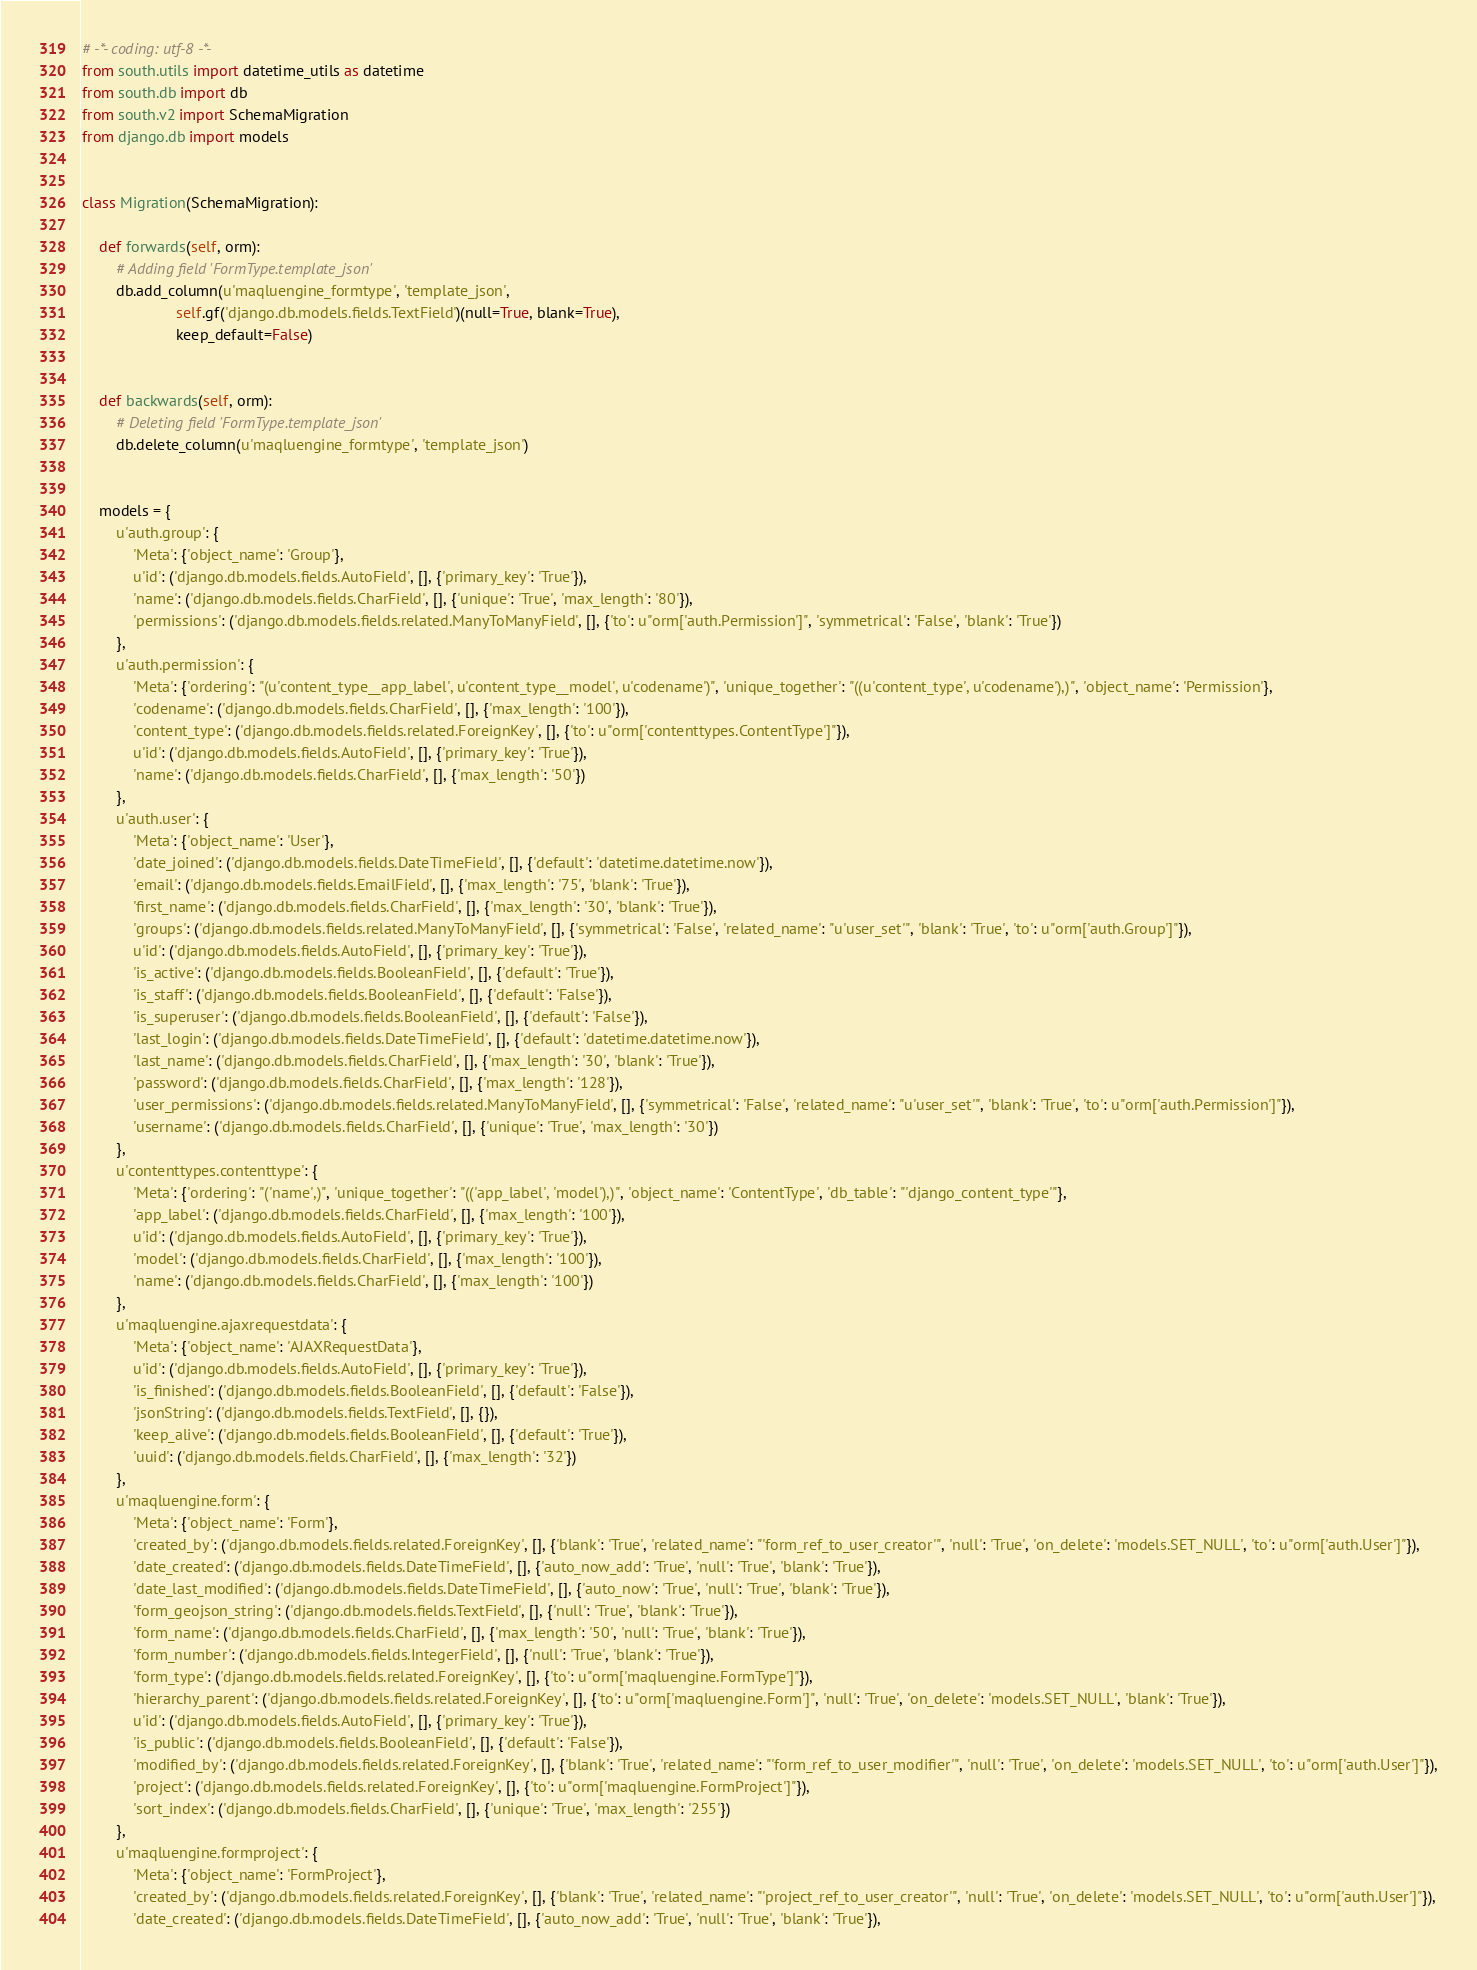Convert code to text. <code><loc_0><loc_0><loc_500><loc_500><_Python_># -*- coding: utf-8 -*-
from south.utils import datetime_utils as datetime
from south.db import db
from south.v2 import SchemaMigration
from django.db import models


class Migration(SchemaMigration):

    def forwards(self, orm):
        # Adding field 'FormType.template_json'
        db.add_column(u'maqluengine_formtype', 'template_json',
                      self.gf('django.db.models.fields.TextField')(null=True, blank=True),
                      keep_default=False)


    def backwards(self, orm):
        # Deleting field 'FormType.template_json'
        db.delete_column(u'maqluengine_formtype', 'template_json')


    models = {
        u'auth.group': {
            'Meta': {'object_name': 'Group'},
            u'id': ('django.db.models.fields.AutoField', [], {'primary_key': 'True'}),
            'name': ('django.db.models.fields.CharField', [], {'unique': 'True', 'max_length': '80'}),
            'permissions': ('django.db.models.fields.related.ManyToManyField', [], {'to': u"orm['auth.Permission']", 'symmetrical': 'False', 'blank': 'True'})
        },
        u'auth.permission': {
            'Meta': {'ordering': "(u'content_type__app_label', u'content_type__model', u'codename')", 'unique_together': "((u'content_type', u'codename'),)", 'object_name': 'Permission'},
            'codename': ('django.db.models.fields.CharField', [], {'max_length': '100'}),
            'content_type': ('django.db.models.fields.related.ForeignKey', [], {'to': u"orm['contenttypes.ContentType']"}),
            u'id': ('django.db.models.fields.AutoField', [], {'primary_key': 'True'}),
            'name': ('django.db.models.fields.CharField', [], {'max_length': '50'})
        },
        u'auth.user': {
            'Meta': {'object_name': 'User'},
            'date_joined': ('django.db.models.fields.DateTimeField', [], {'default': 'datetime.datetime.now'}),
            'email': ('django.db.models.fields.EmailField', [], {'max_length': '75', 'blank': 'True'}),
            'first_name': ('django.db.models.fields.CharField', [], {'max_length': '30', 'blank': 'True'}),
            'groups': ('django.db.models.fields.related.ManyToManyField', [], {'symmetrical': 'False', 'related_name': "u'user_set'", 'blank': 'True', 'to': u"orm['auth.Group']"}),
            u'id': ('django.db.models.fields.AutoField', [], {'primary_key': 'True'}),
            'is_active': ('django.db.models.fields.BooleanField', [], {'default': 'True'}),
            'is_staff': ('django.db.models.fields.BooleanField', [], {'default': 'False'}),
            'is_superuser': ('django.db.models.fields.BooleanField', [], {'default': 'False'}),
            'last_login': ('django.db.models.fields.DateTimeField', [], {'default': 'datetime.datetime.now'}),
            'last_name': ('django.db.models.fields.CharField', [], {'max_length': '30', 'blank': 'True'}),
            'password': ('django.db.models.fields.CharField', [], {'max_length': '128'}),
            'user_permissions': ('django.db.models.fields.related.ManyToManyField', [], {'symmetrical': 'False', 'related_name': "u'user_set'", 'blank': 'True', 'to': u"orm['auth.Permission']"}),
            'username': ('django.db.models.fields.CharField', [], {'unique': 'True', 'max_length': '30'})
        },
        u'contenttypes.contenttype': {
            'Meta': {'ordering': "('name',)", 'unique_together': "(('app_label', 'model'),)", 'object_name': 'ContentType', 'db_table': "'django_content_type'"},
            'app_label': ('django.db.models.fields.CharField', [], {'max_length': '100'}),
            u'id': ('django.db.models.fields.AutoField', [], {'primary_key': 'True'}),
            'model': ('django.db.models.fields.CharField', [], {'max_length': '100'}),
            'name': ('django.db.models.fields.CharField', [], {'max_length': '100'})
        },
        u'maqluengine.ajaxrequestdata': {
            'Meta': {'object_name': 'AJAXRequestData'},
            u'id': ('django.db.models.fields.AutoField', [], {'primary_key': 'True'}),
            'is_finished': ('django.db.models.fields.BooleanField', [], {'default': 'False'}),
            'jsonString': ('django.db.models.fields.TextField', [], {}),
            'keep_alive': ('django.db.models.fields.BooleanField', [], {'default': 'True'}),
            'uuid': ('django.db.models.fields.CharField', [], {'max_length': '32'})
        },
        u'maqluengine.form': {
            'Meta': {'object_name': 'Form'},
            'created_by': ('django.db.models.fields.related.ForeignKey', [], {'blank': 'True', 'related_name': "'form_ref_to_user_creator'", 'null': 'True', 'on_delete': 'models.SET_NULL', 'to': u"orm['auth.User']"}),
            'date_created': ('django.db.models.fields.DateTimeField', [], {'auto_now_add': 'True', 'null': 'True', 'blank': 'True'}),
            'date_last_modified': ('django.db.models.fields.DateTimeField', [], {'auto_now': 'True', 'null': 'True', 'blank': 'True'}),
            'form_geojson_string': ('django.db.models.fields.TextField', [], {'null': 'True', 'blank': 'True'}),
            'form_name': ('django.db.models.fields.CharField', [], {'max_length': '50', 'null': 'True', 'blank': 'True'}),
            'form_number': ('django.db.models.fields.IntegerField', [], {'null': 'True', 'blank': 'True'}),
            'form_type': ('django.db.models.fields.related.ForeignKey', [], {'to': u"orm['maqluengine.FormType']"}),
            'hierarchy_parent': ('django.db.models.fields.related.ForeignKey', [], {'to': u"orm['maqluengine.Form']", 'null': 'True', 'on_delete': 'models.SET_NULL', 'blank': 'True'}),
            u'id': ('django.db.models.fields.AutoField', [], {'primary_key': 'True'}),
            'is_public': ('django.db.models.fields.BooleanField', [], {'default': 'False'}),
            'modified_by': ('django.db.models.fields.related.ForeignKey', [], {'blank': 'True', 'related_name': "'form_ref_to_user_modifier'", 'null': 'True', 'on_delete': 'models.SET_NULL', 'to': u"orm['auth.User']"}),
            'project': ('django.db.models.fields.related.ForeignKey', [], {'to': u"orm['maqluengine.FormProject']"}),
            'sort_index': ('django.db.models.fields.CharField', [], {'unique': 'True', 'max_length': '255'})
        },
        u'maqluengine.formproject': {
            'Meta': {'object_name': 'FormProject'},
            'created_by': ('django.db.models.fields.related.ForeignKey', [], {'blank': 'True', 'related_name': "'project_ref_to_user_creator'", 'null': 'True', 'on_delete': 'models.SET_NULL', 'to': u"orm['auth.User']"}),
            'date_created': ('django.db.models.fields.DateTimeField', [], {'auto_now_add': 'True', 'null': 'True', 'blank': 'True'}),</code> 